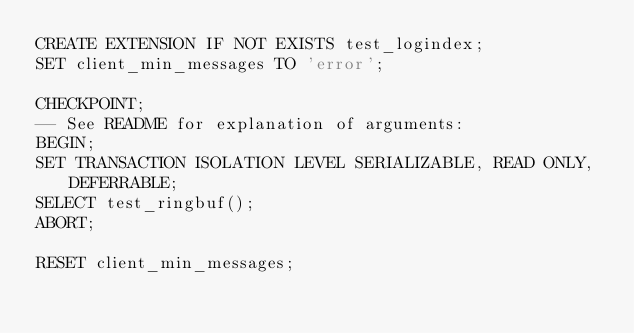<code> <loc_0><loc_0><loc_500><loc_500><_SQL_>CREATE EXTENSION IF NOT EXISTS test_logindex;
SET client_min_messages TO 'error';

CHECKPOINT;
-- See README for explanation of arguments:
BEGIN;
SET TRANSACTION ISOLATION LEVEL SERIALIZABLE, READ ONLY, DEFERRABLE;
SELECT test_ringbuf();
ABORT;

RESET client_min_messages;
</code> 